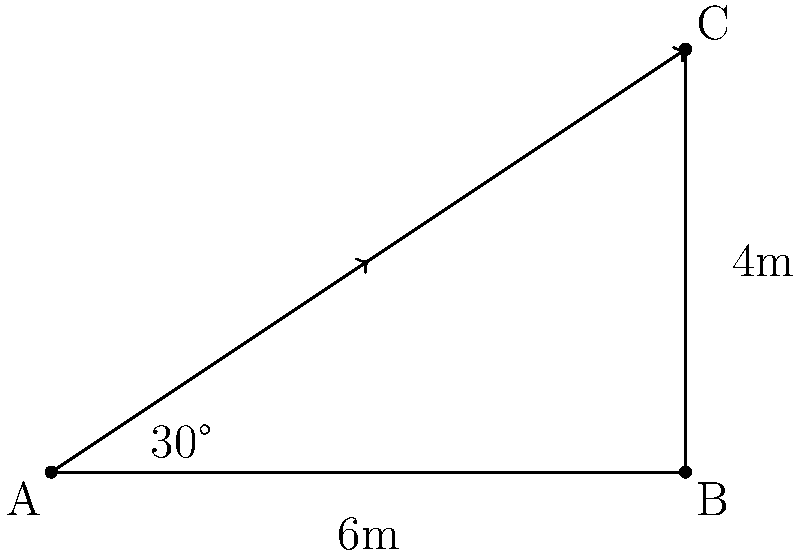A smart security camera needs to be installed at point A to cover a rectangular area ABCĐ. The width of the area is 6 meters, and the height is 4 meters. What should be the minimum viewing angle of the camera to ensure complete coverage of the area? To determine the minimum viewing angle of the camera, we need to follow these steps:

1. Identify the triangle formed by the camera's view:
   The triangle is ABC, where A is the camera position, and BC is the diagonal of the rectangular area.

2. Calculate the length of the diagonal BC using the Pythagorean theorem:
   $$BC = \sqrt{6^2 + 4^2} = \sqrt{36 + 16} = \sqrt{52} \approx 7.21 \text{ meters}$$

3. Use the arctangent function to calculate the angle:
   The viewing angle is twice the angle between AB and AC.
   $$\theta = 2 \cdot \tan^{-1}\left(\frac{4}{6}\right)$$

4. Calculate the result:
   $$\theta = 2 \cdot \tan^{-1}\left(\frac{2}{3}\right) \approx 2 \cdot 33.69° = 67.38°$$

5. Round up to the nearest degree to ensure complete coverage:
   $$\theta \approx 68°$$

Therefore, the minimum viewing angle of the camera should be 68° to cover the entire rectangular area.
Answer: 68° 